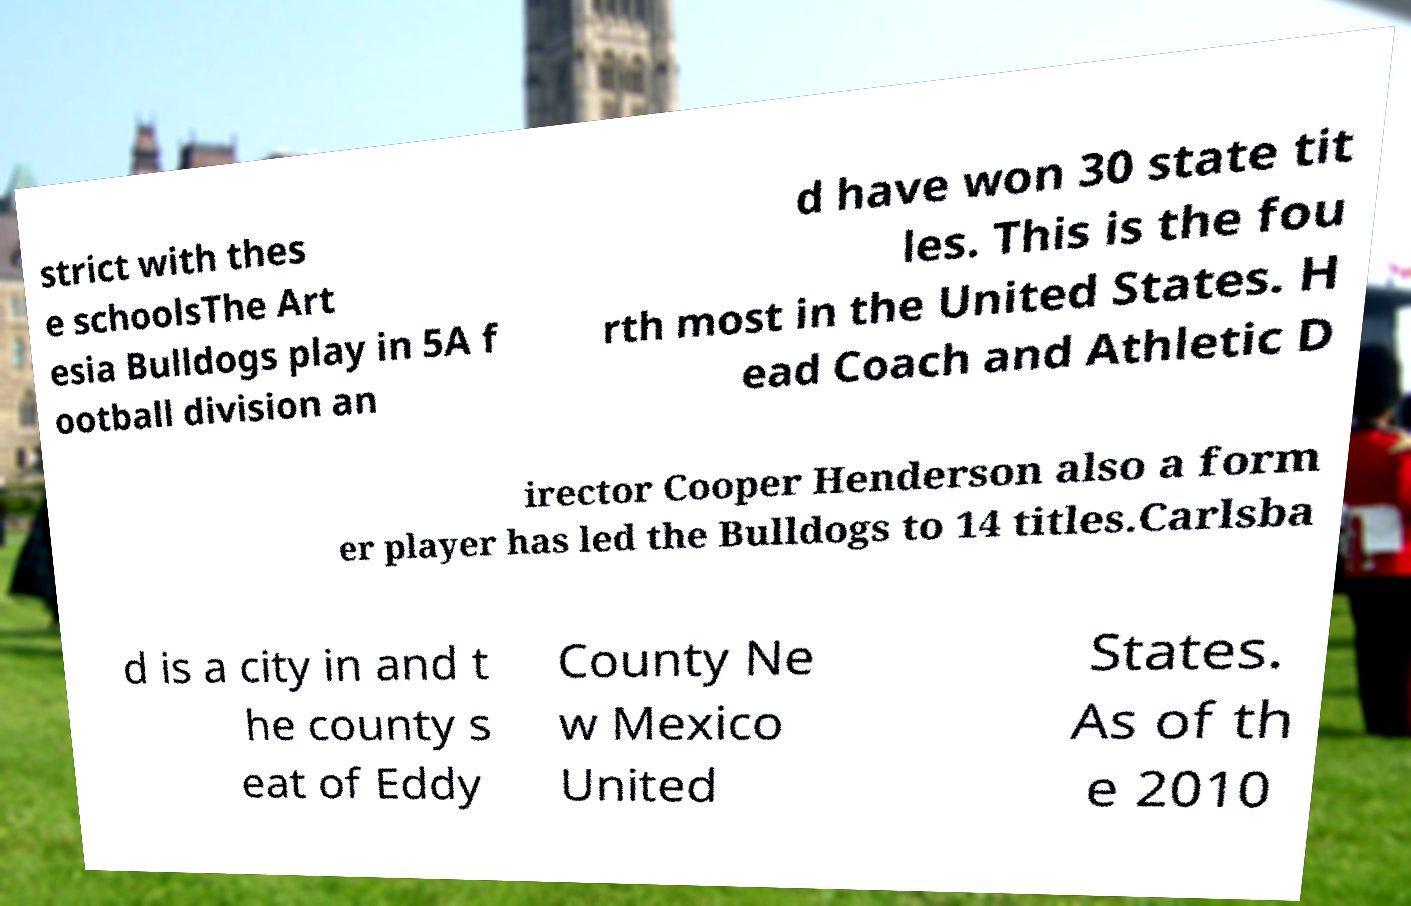I need the written content from this picture converted into text. Can you do that? strict with thes e schoolsThe Art esia Bulldogs play in 5A f ootball division an d have won 30 state tit les. This is the fou rth most in the United States. H ead Coach and Athletic D irector Cooper Henderson also a form er player has led the Bulldogs to 14 titles.Carlsba d is a city in and t he county s eat of Eddy County Ne w Mexico United States. As of th e 2010 